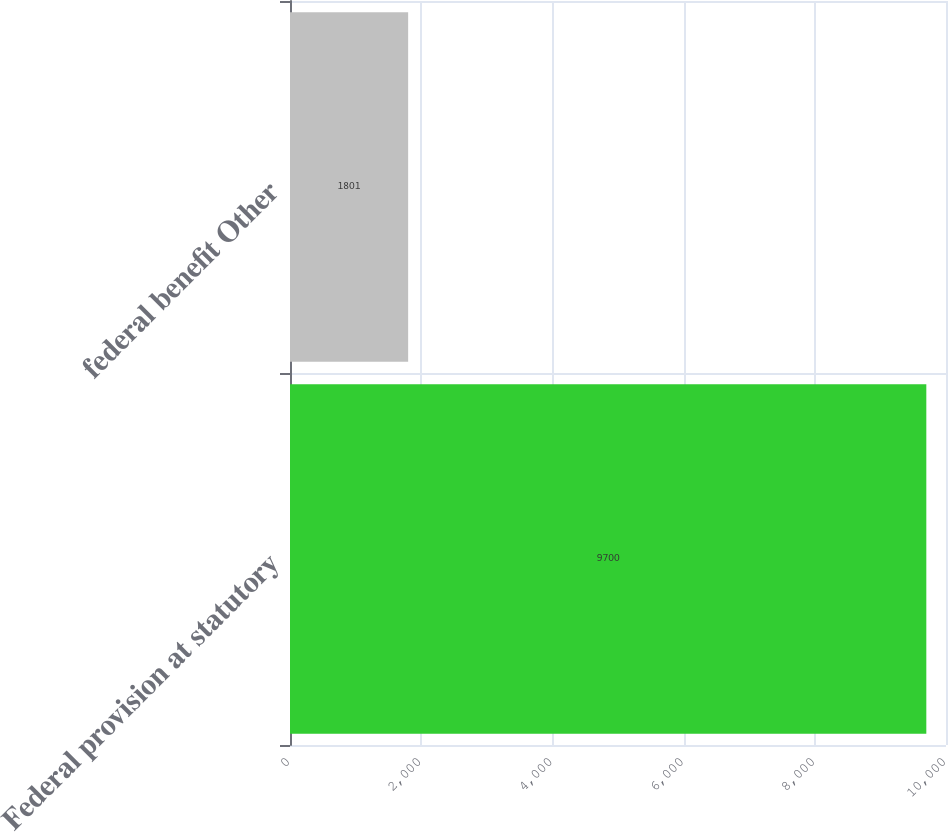<chart> <loc_0><loc_0><loc_500><loc_500><bar_chart><fcel>Federal provision at statutory<fcel>federal benefit Other<nl><fcel>9700<fcel>1801<nl></chart> 